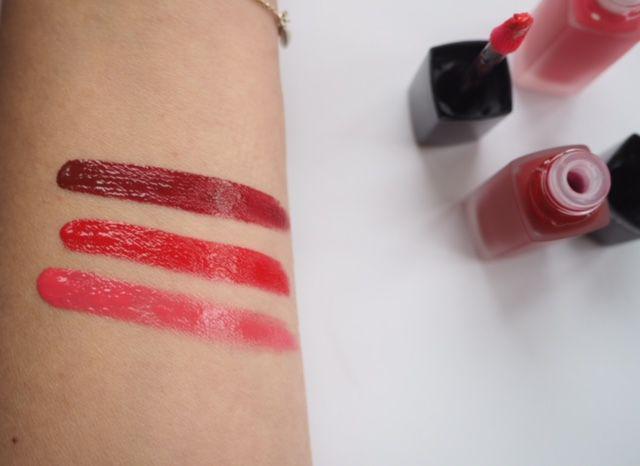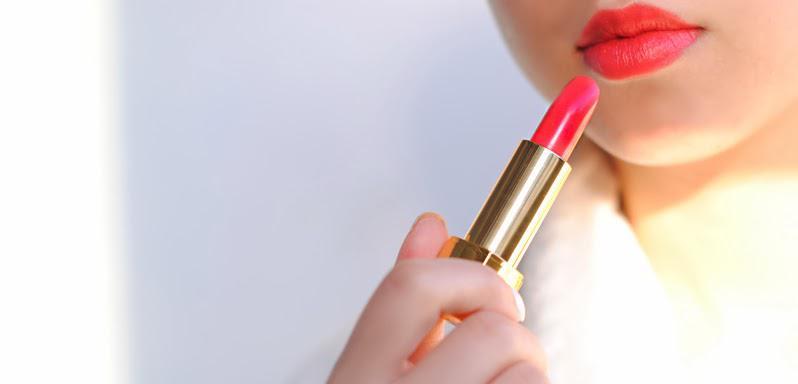The first image is the image on the left, the second image is the image on the right. For the images shown, is this caption "Each image shows an arm comparing the shades of at least two lipstick colors." true? Answer yes or no. No. The first image is the image on the left, the second image is the image on the right. Examine the images to the left and right. Is the description "The left image shows skin with two lipstick stripes on it, and the right image shows the top of a hand with three lipstick stripes." accurate? Answer yes or no. No. 